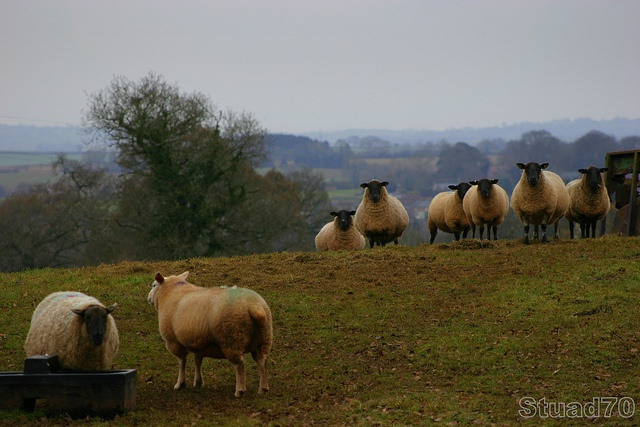Describe the objects in this image and their specific colors. I can see sheep in darkgray, black, maroon, and olive tones, sheep in darkgray, black, olive, maroon, and gray tones, sheep in darkgray, black, maroon, and tan tones, sheep in darkgray, black, maroon, olive, and gray tones, and sheep in darkgray, black, maroon, and gray tones in this image. 